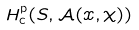Convert formula to latex. <formula><loc_0><loc_0><loc_500><loc_500>H _ { \text {c} } ^ { \text {p} } ( S , \mathcal { A } ( x , \chi ) )</formula> 